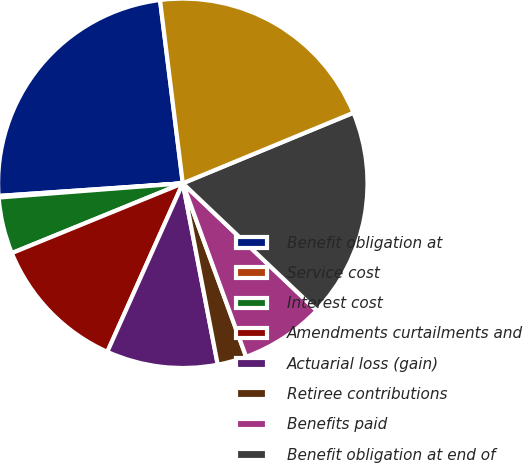<chart> <loc_0><loc_0><loc_500><loc_500><pie_chart><fcel>Benefit obligation at<fcel>Service cost<fcel>Interest cost<fcel>Amendments curtailments and<fcel>Actuarial loss (gain)<fcel>Retiree contributions<fcel>Benefits paid<fcel>Benefit obligation at end of<fcel>Funded status<nl><fcel>24.12%<fcel>0.14%<fcel>4.94%<fcel>12.13%<fcel>9.73%<fcel>2.54%<fcel>7.34%<fcel>18.33%<fcel>20.73%<nl></chart> 